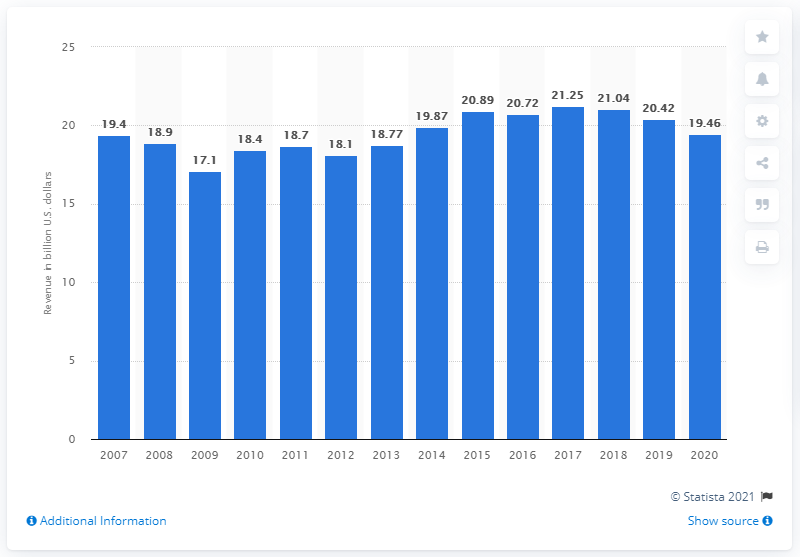Give some essential details in this illustration. In 2019, Whirlpool generated a total revenue of $19.87 billion. Whirlpool reported a revenue of 19.46 billion dollars in 2020. Whirlpool last experienced a similar drop in net sales in 2009. 